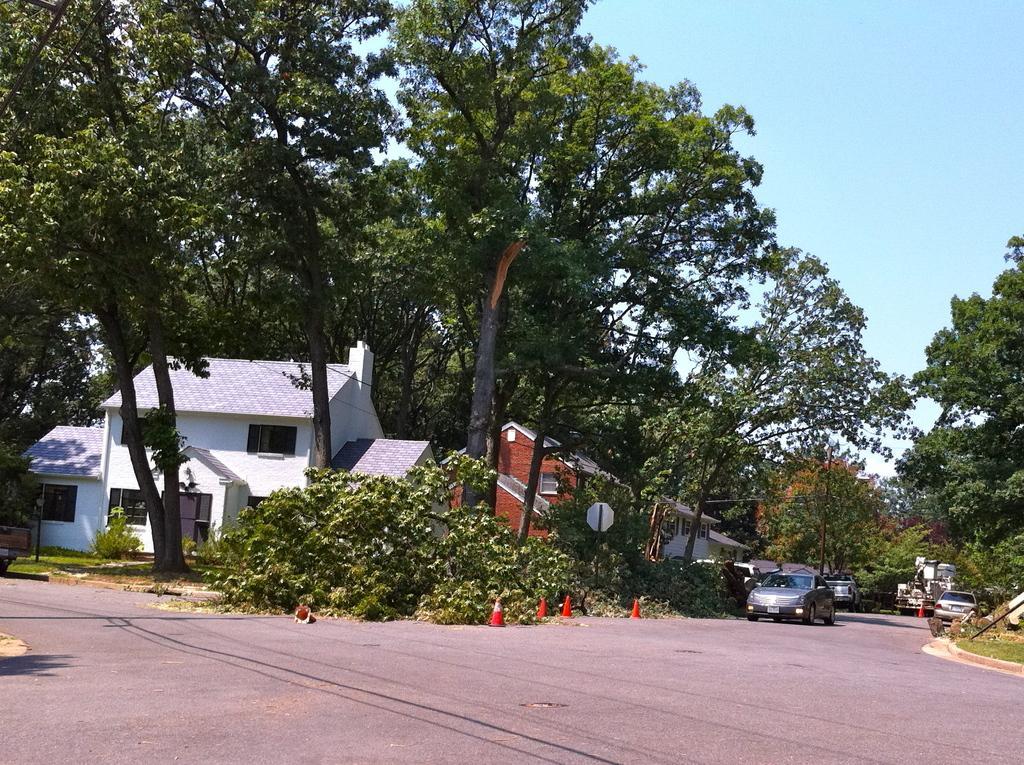In one or two sentences, can you explain what this image depicts? In the background we can see the sky. In this picture we can see the houses, windows, plants, trees and the green grass. In this picture we can see the vehicles on the road. We can see the traffic cones, board and a pole. 